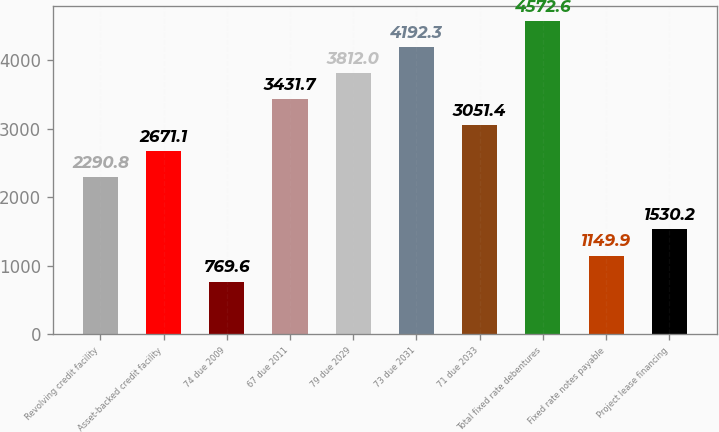Convert chart. <chart><loc_0><loc_0><loc_500><loc_500><bar_chart><fcel>Revolving credit facility<fcel>Asset-backed credit facility<fcel>74 due 2009<fcel>67 due 2011<fcel>79 due 2029<fcel>73 due 2031<fcel>71 due 2033<fcel>Total fixed rate debentures<fcel>Fixed rate notes payable<fcel>Project lease financing<nl><fcel>2290.8<fcel>2671.1<fcel>769.6<fcel>3431.7<fcel>3812<fcel>4192.3<fcel>3051.4<fcel>4572.6<fcel>1149.9<fcel>1530.2<nl></chart> 